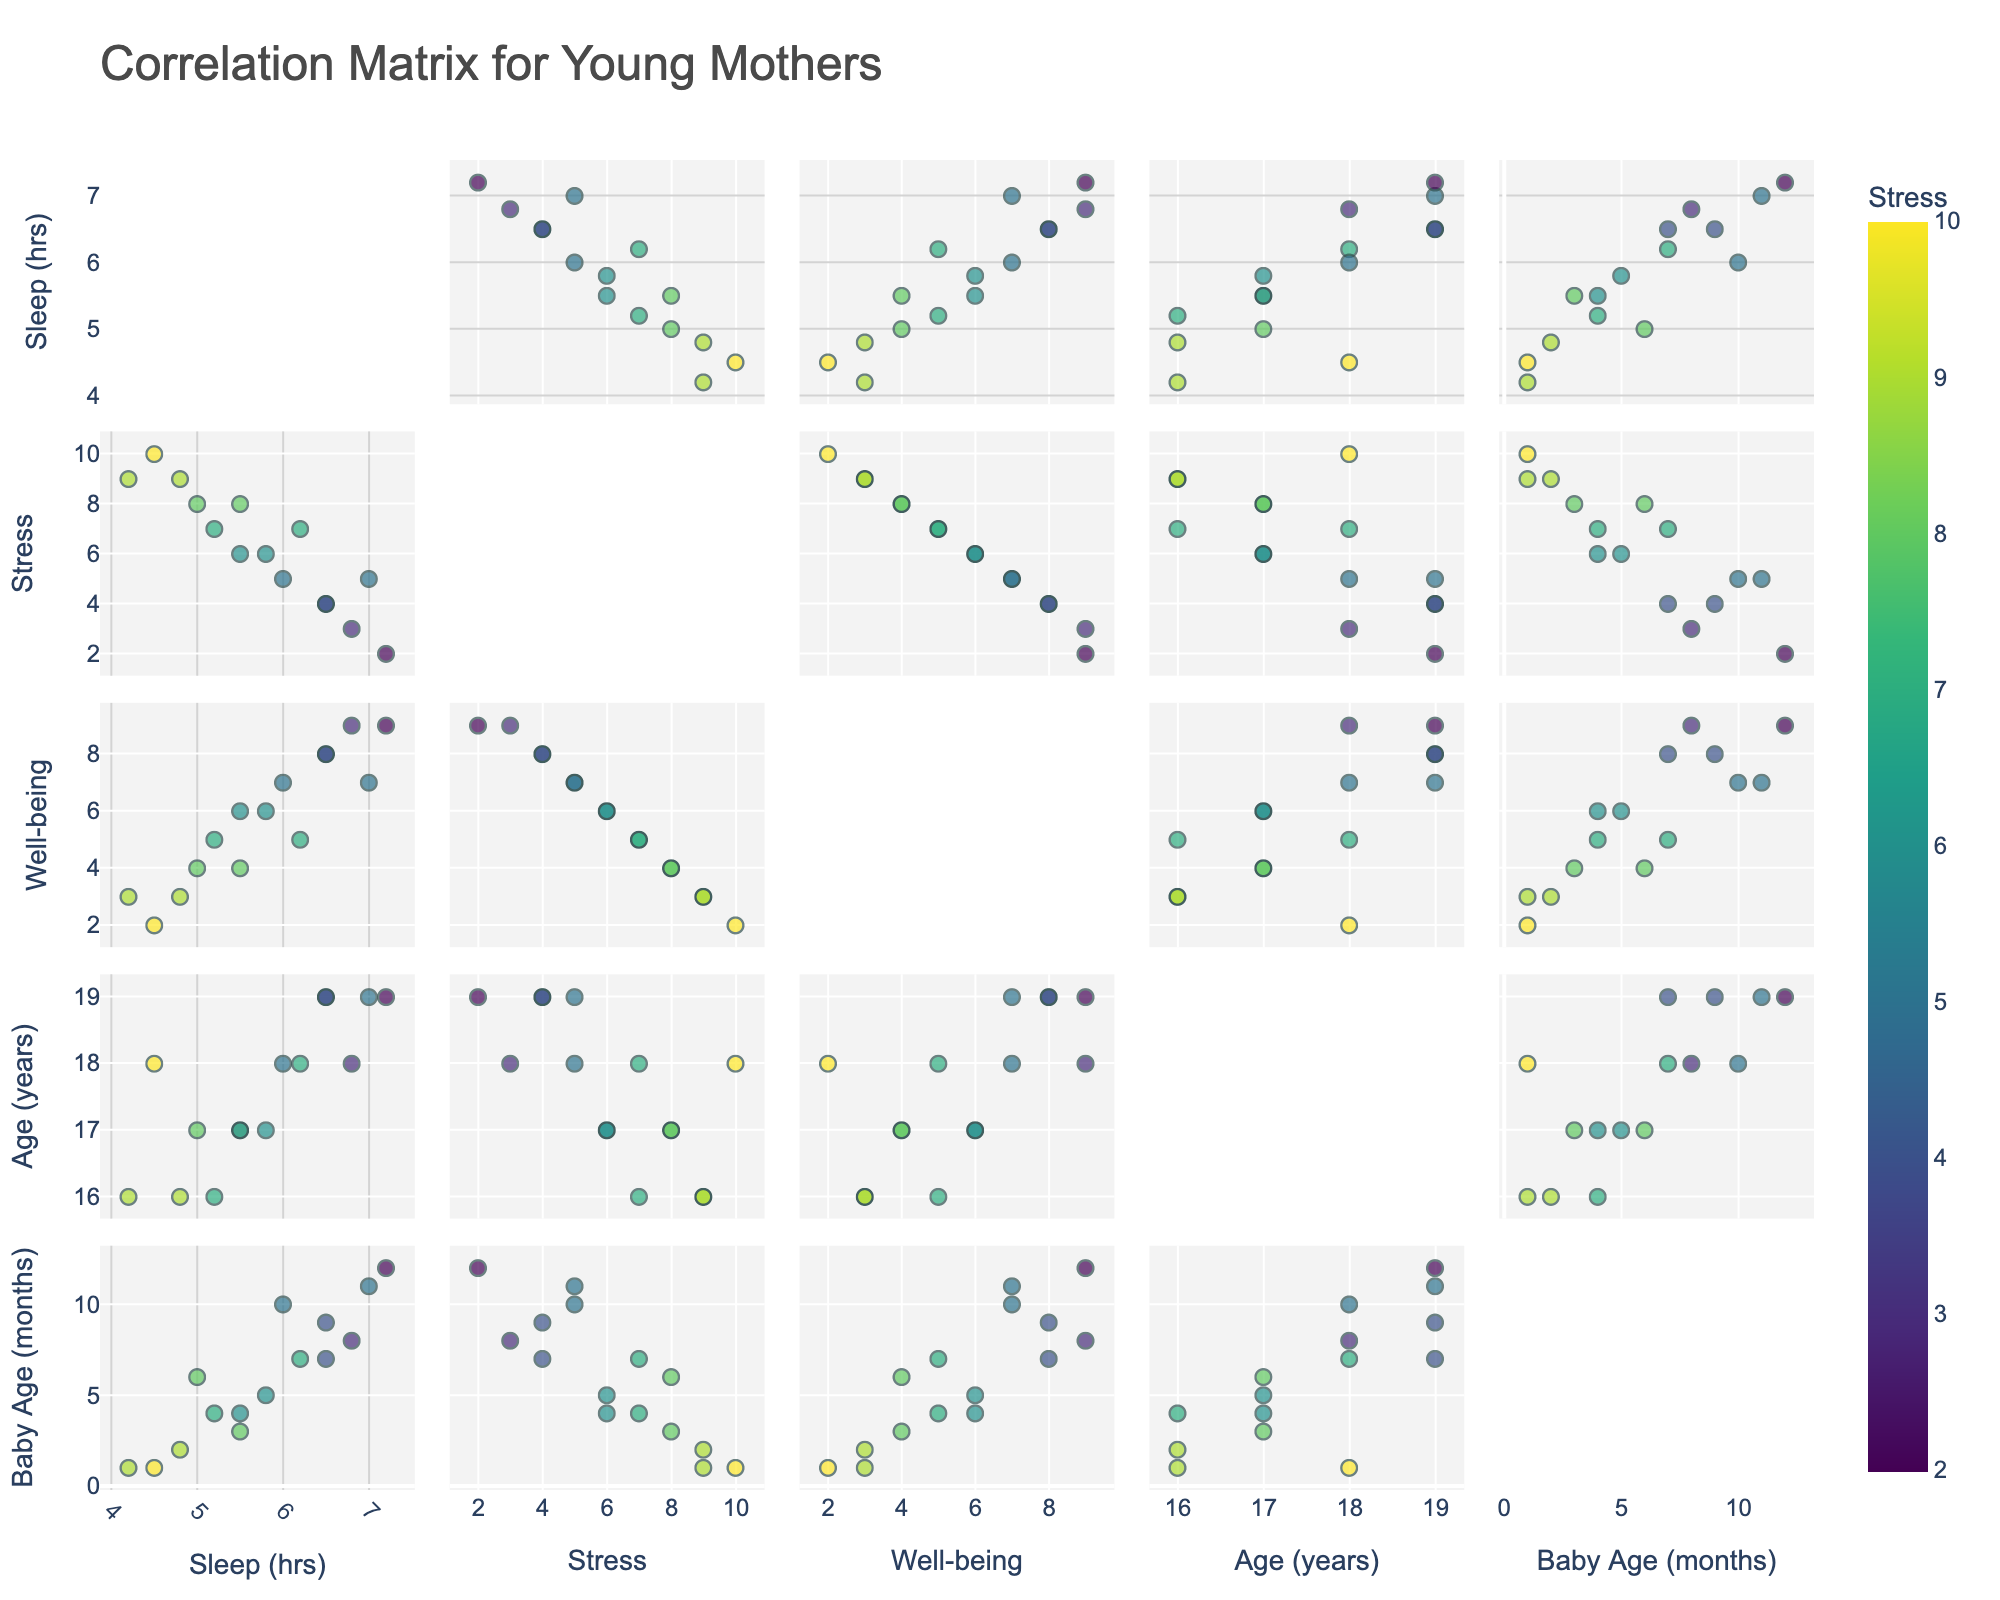How many dimensions are represented in the scatterplot matrix? By looking at the labels on the scatterplot matrix, we can count the different axes present. They represent 'Sleep (hrs)', 'Stress', 'Well-being', 'Age (years)', and 'Baby Age (months)'.
Answer: 5 What is the title of the figure? The title is displayed at the top of the scatterplot matrix.
Answer: Correlation Matrix for Young Mothers Which variable is used for color-coding the points in the scatterplot matrix? The color scheme of the points varies based on a specific variable. In the legend or color bar, 'Stress' is identified.
Answer: Stress How many data points are in the scatterplot matrix? To determine the number of points, count the entries in the dataset. Each entry is represented as a point in every cell of the matrix.
Answer: 15 What is the range of the 'Well-being' scores? By checking the 'Well-being' axis, note the minimum and maximum values displayed.
Answer: 2 to 9 Which variable seems to have an inverse relationship with 'Stress Level'? By examining the scatterplots involving 'Stress Level', observe any clear inverse trends, such as between 'Sleep (hrs)' and 'Stress Level'. Fewer sleep hours generally correlate with higher stress levels.
Answer: Sleep (hrs) Compare 'Well-being' scores for the data points with high stress levels and low stress levels. What do you observe? Check the scatterplots involving 'Well-being' and compare points color-coded with high stress (darker colors) versus low stress (lighter colors). Higher stress levels tend to link with lower 'Well-being' scores.
Answer: Higher stress often correlates with lower well-being Is there a trend between 'Baby Age (months)' and 'Sleep (hrs)'? Observe the scatterplot comparing 'Baby Age (months)' with 'Sleep (hrs)'. Identify if there's a noticeable trend, considering increases or decreases in the data distribution.
Answer: Slight positive trend; older babies correlate with slightly more sleep for mothers Which two dimensions show the most scattered relationship, indicating low correlation? Identify scatterplots with points widely spread in all directions. The scatterplot for 'Stress' and 'Baby Age (months)' shows little apparent correlation.
Answer: Stress and Baby Age (months) Do older mothers generally report higher or lower stress levels? By checking the scatterplot of 'Age (years)' and 'Stress', observe the distribution of points and their color coding for stress levels. Look for clusters of higher or lower age groups with certain stress levels.
Answer: Generally lower 